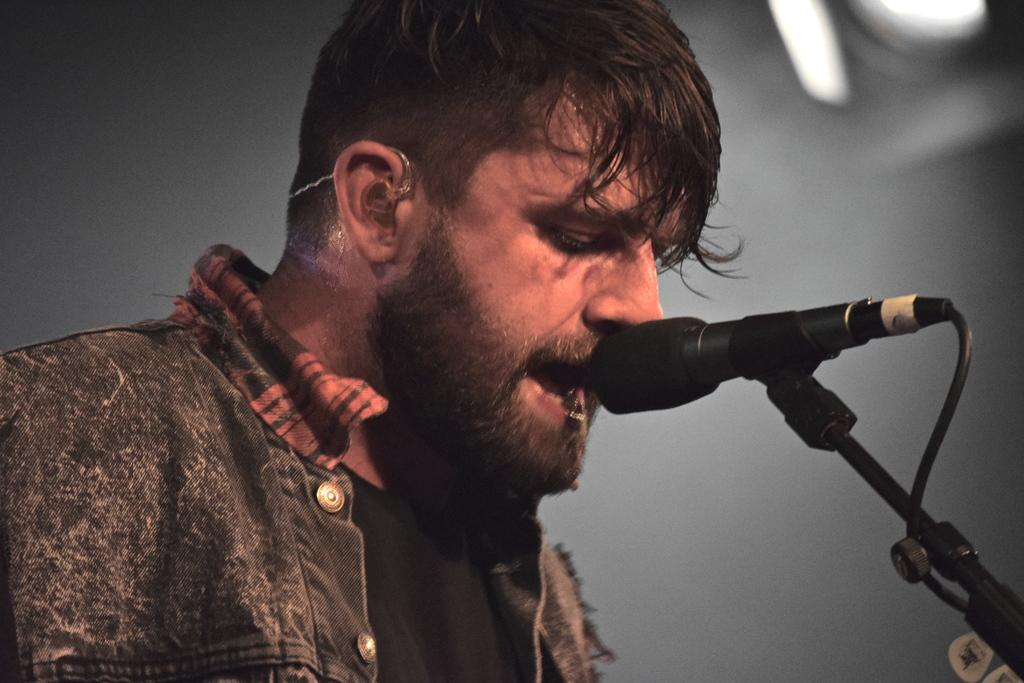Who is the main subject in the image? There is a man in the image. What object is in front of the man? There is a mic in front of the man. What can be seen in the background of the image? There is a light visible in the background of the image. What is the value of the stone that the man is holding in the image? There is no stone present in the image, and therefore no value can be determined. 